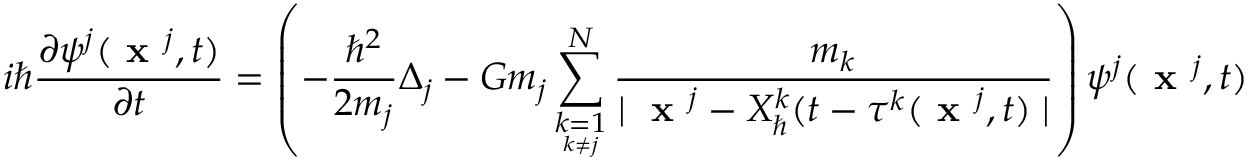Convert formula to latex. <formula><loc_0><loc_0><loc_500><loc_500>i \hbar { } \partial \psi ^ { j } ( x ^ { j } , t ) } { \partial t } = \left ( - \frac { \hbar { ^ } { 2 } } { 2 m _ { j } } \Delta _ { j } - G m _ { j } \sum _ { \underset { k \neq j } { k = 1 } } ^ { N } \frac { m _ { k } } { | x ^ { j } - X _ { } ^ { k } ( t - \tau ^ { k } ( x ^ { j } , t ) | } \right ) \psi ^ { j } ( x ^ { j } , t )</formula> 